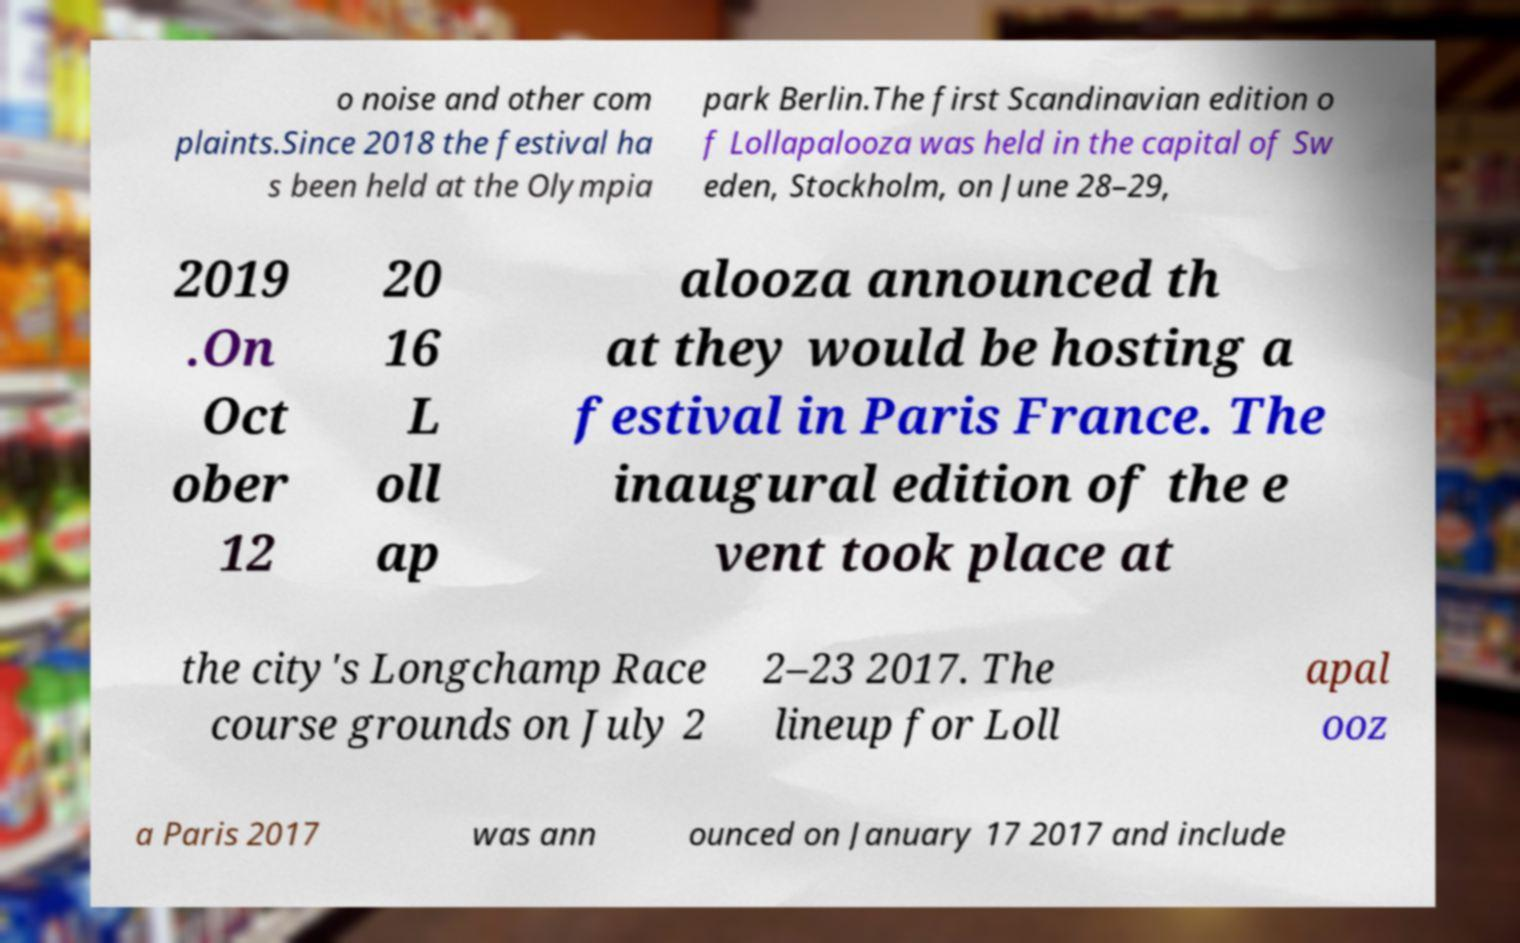There's text embedded in this image that I need extracted. Can you transcribe it verbatim? o noise and other com plaints.Since 2018 the festival ha s been held at the Olympia park Berlin.The first Scandinavian edition o f Lollapalooza was held in the capital of Sw eden, Stockholm, on June 28–29, 2019 .On Oct ober 12 20 16 L oll ap alooza announced th at they would be hosting a festival in Paris France. The inaugural edition of the e vent took place at the city's Longchamp Race course grounds on July 2 2–23 2017. The lineup for Loll apal ooz a Paris 2017 was ann ounced on January 17 2017 and include 